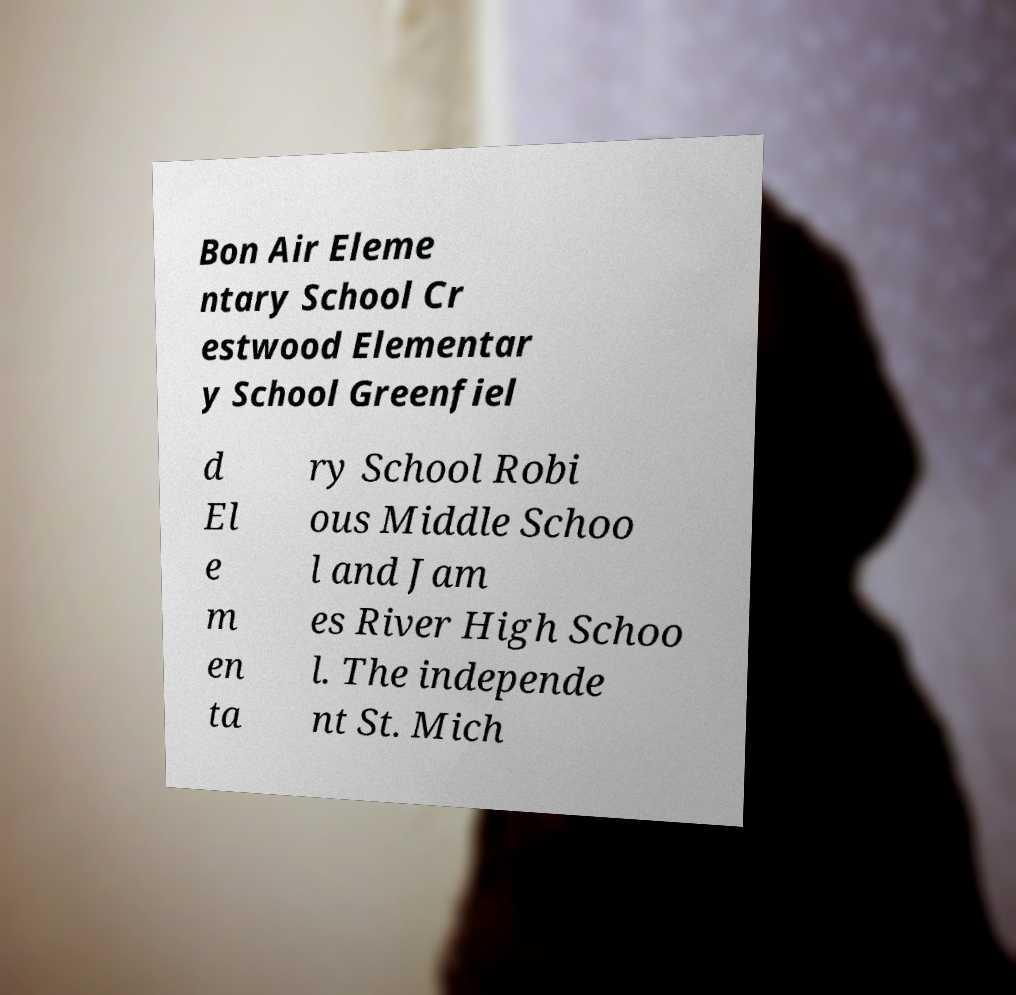Please identify and transcribe the text found in this image. Bon Air Eleme ntary School Cr estwood Elementar y School Greenfiel d El e m en ta ry School Robi ous Middle Schoo l and Jam es River High Schoo l. The independe nt St. Mich 